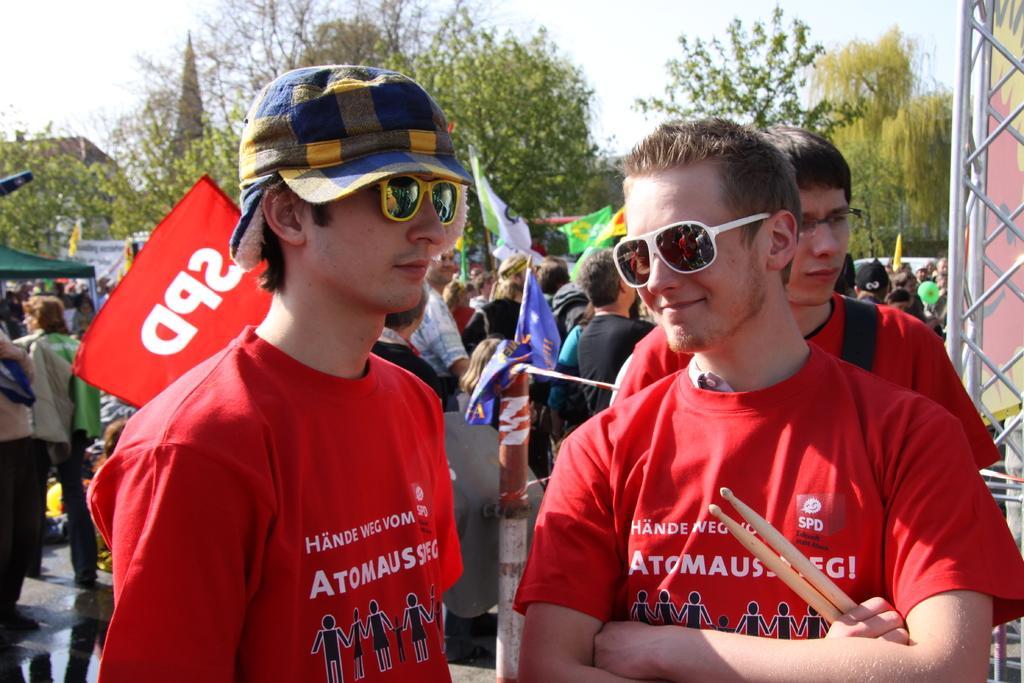Describe this image in one or two sentences. This image is clicked outside. There are so many people in the middle, who are holding flags. In the front there are two people, who are wearing red dress, they are goggles. One of them is holding two sticks. There are trees at the top. There is sky at the top. 